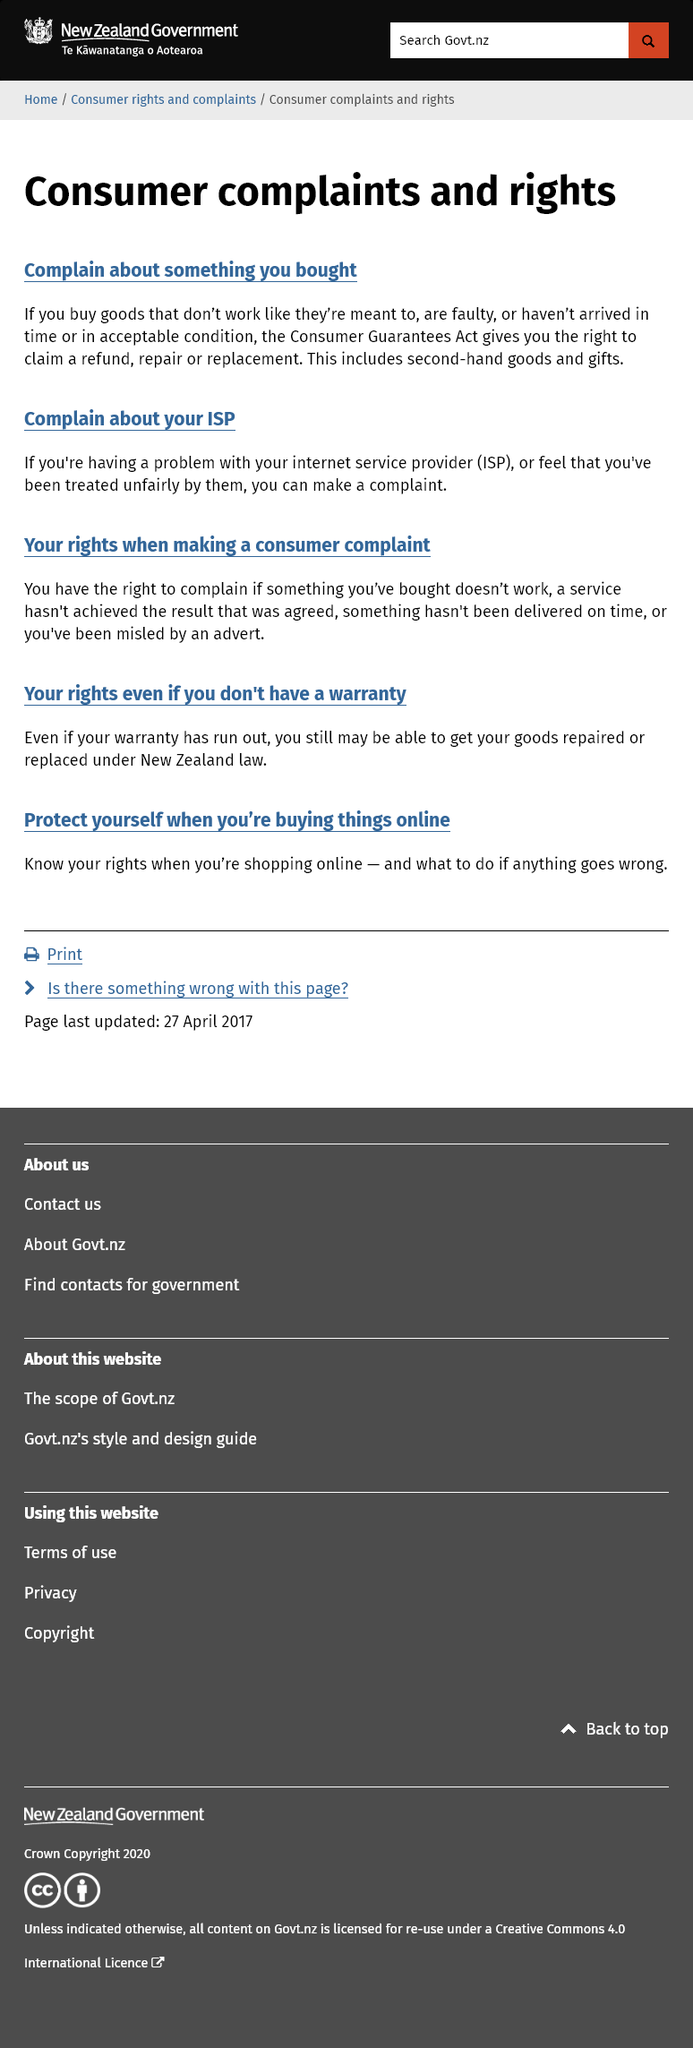Identify some key points in this picture. The Consumer Guarantees Act gives you the right to claim a refund, repair, or replacement. You have the right to complain if the goods you have purchased are faulty or if the service agreed upon has not been achieved. The Consumer Guarantees Act applies to second-hand goods and gifts. 